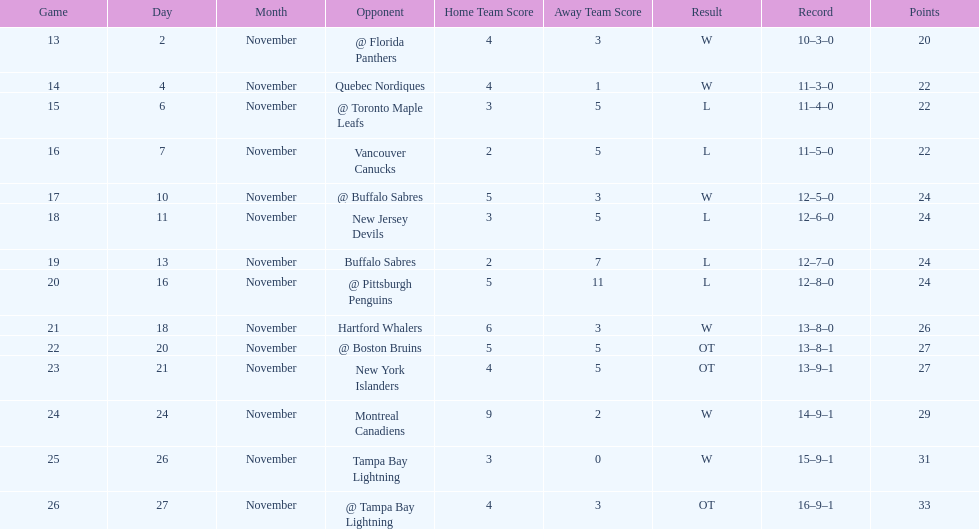The 1993-1994 flyers missed the playoffs again. how many consecutive seasons up until 93-94 did the flyers miss the playoffs? 5. 